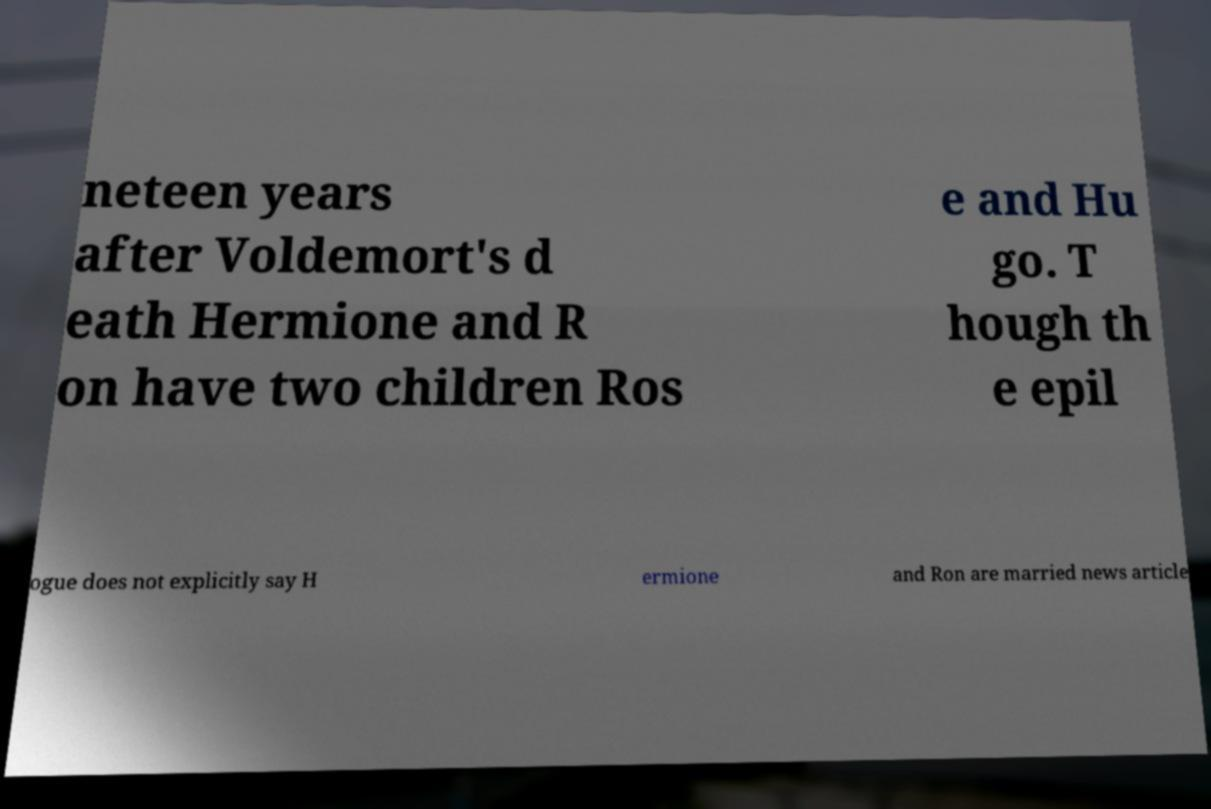There's text embedded in this image that I need extracted. Can you transcribe it verbatim? neteen years after Voldemort's d eath Hermione and R on have two children Ros e and Hu go. T hough th e epil ogue does not explicitly say H ermione and Ron are married news article 